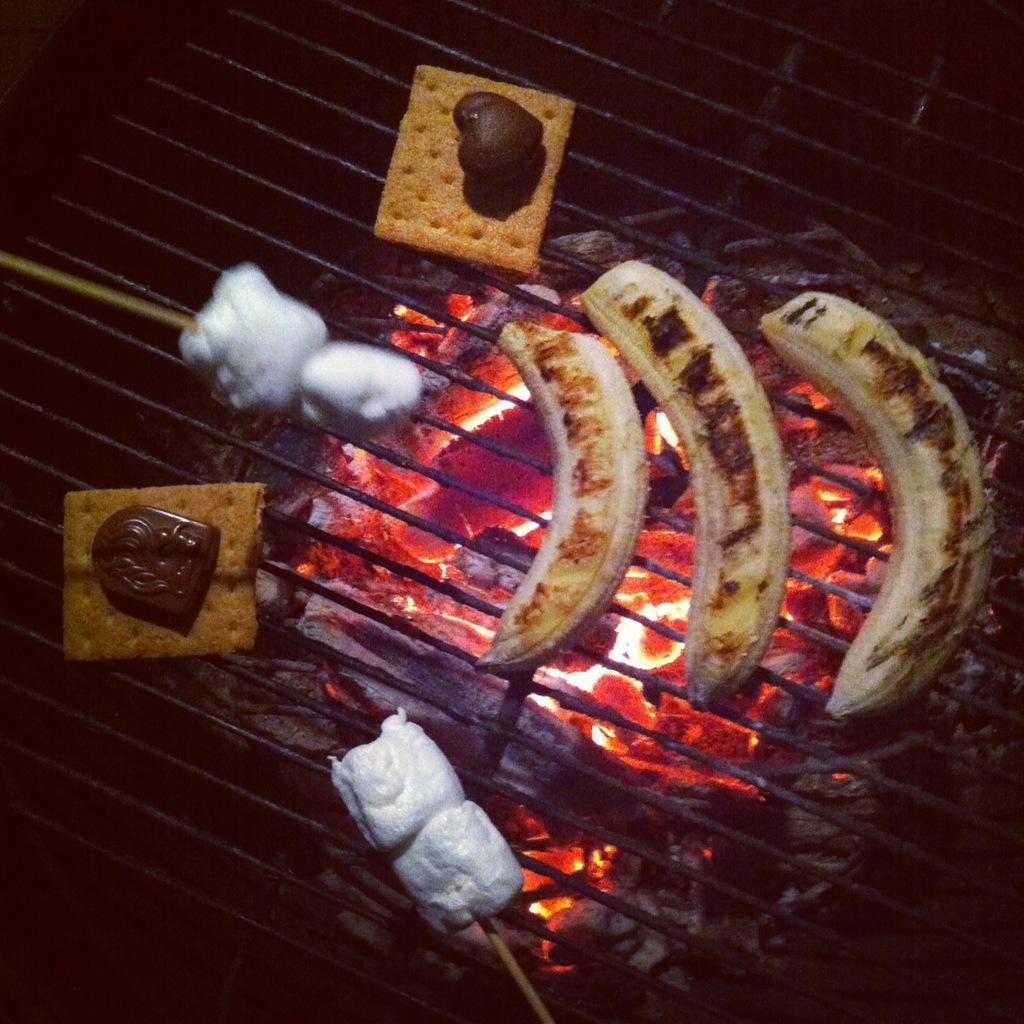Can you describe this image briefly? In this picture we can see food items on a grill and below this girl we can see a fire. 